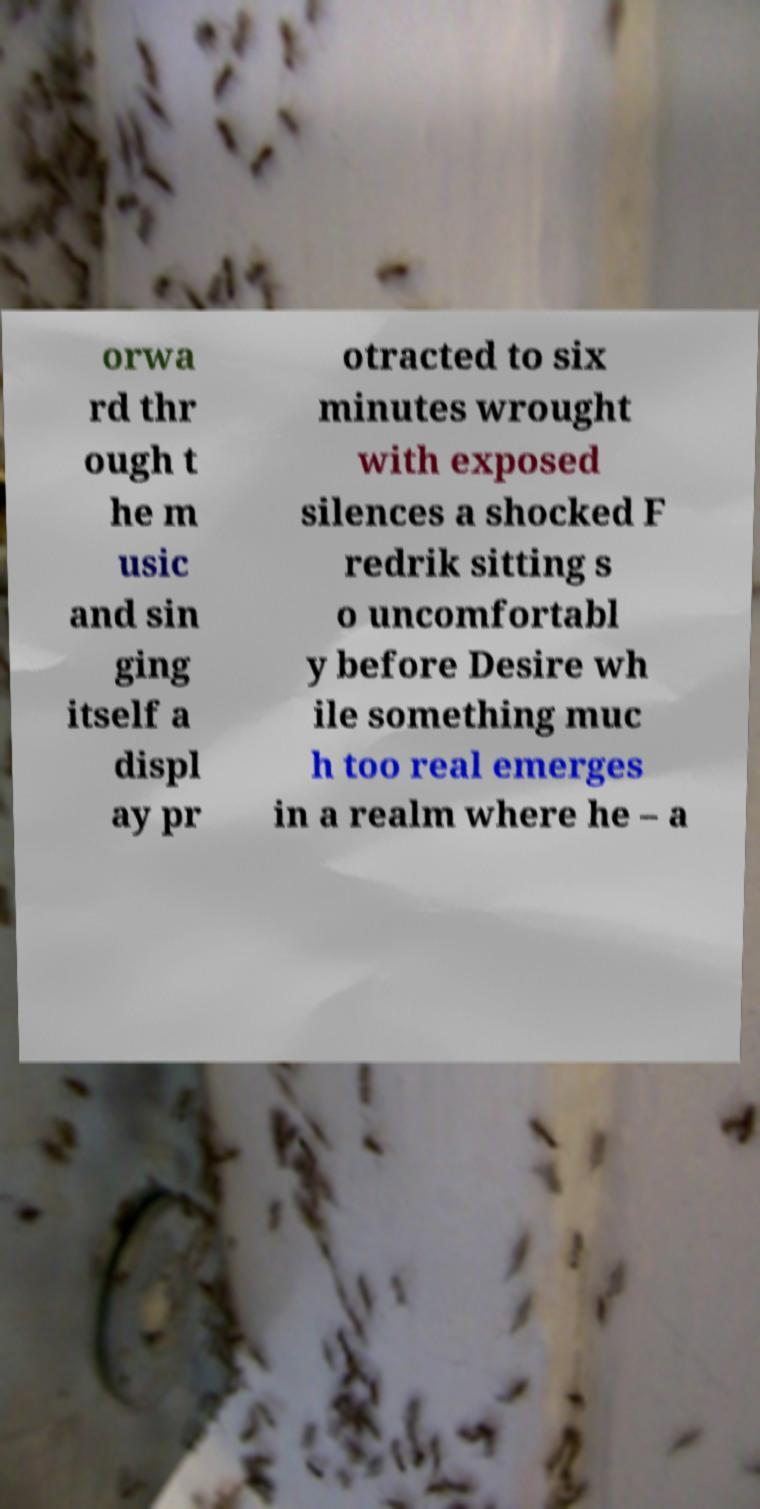Could you assist in decoding the text presented in this image and type it out clearly? orwa rd thr ough t he m usic and sin ging itself a displ ay pr otracted to six minutes wrought with exposed silences a shocked F redrik sitting s o uncomfortabl y before Desire wh ile something muc h too real emerges in a realm where he – a 